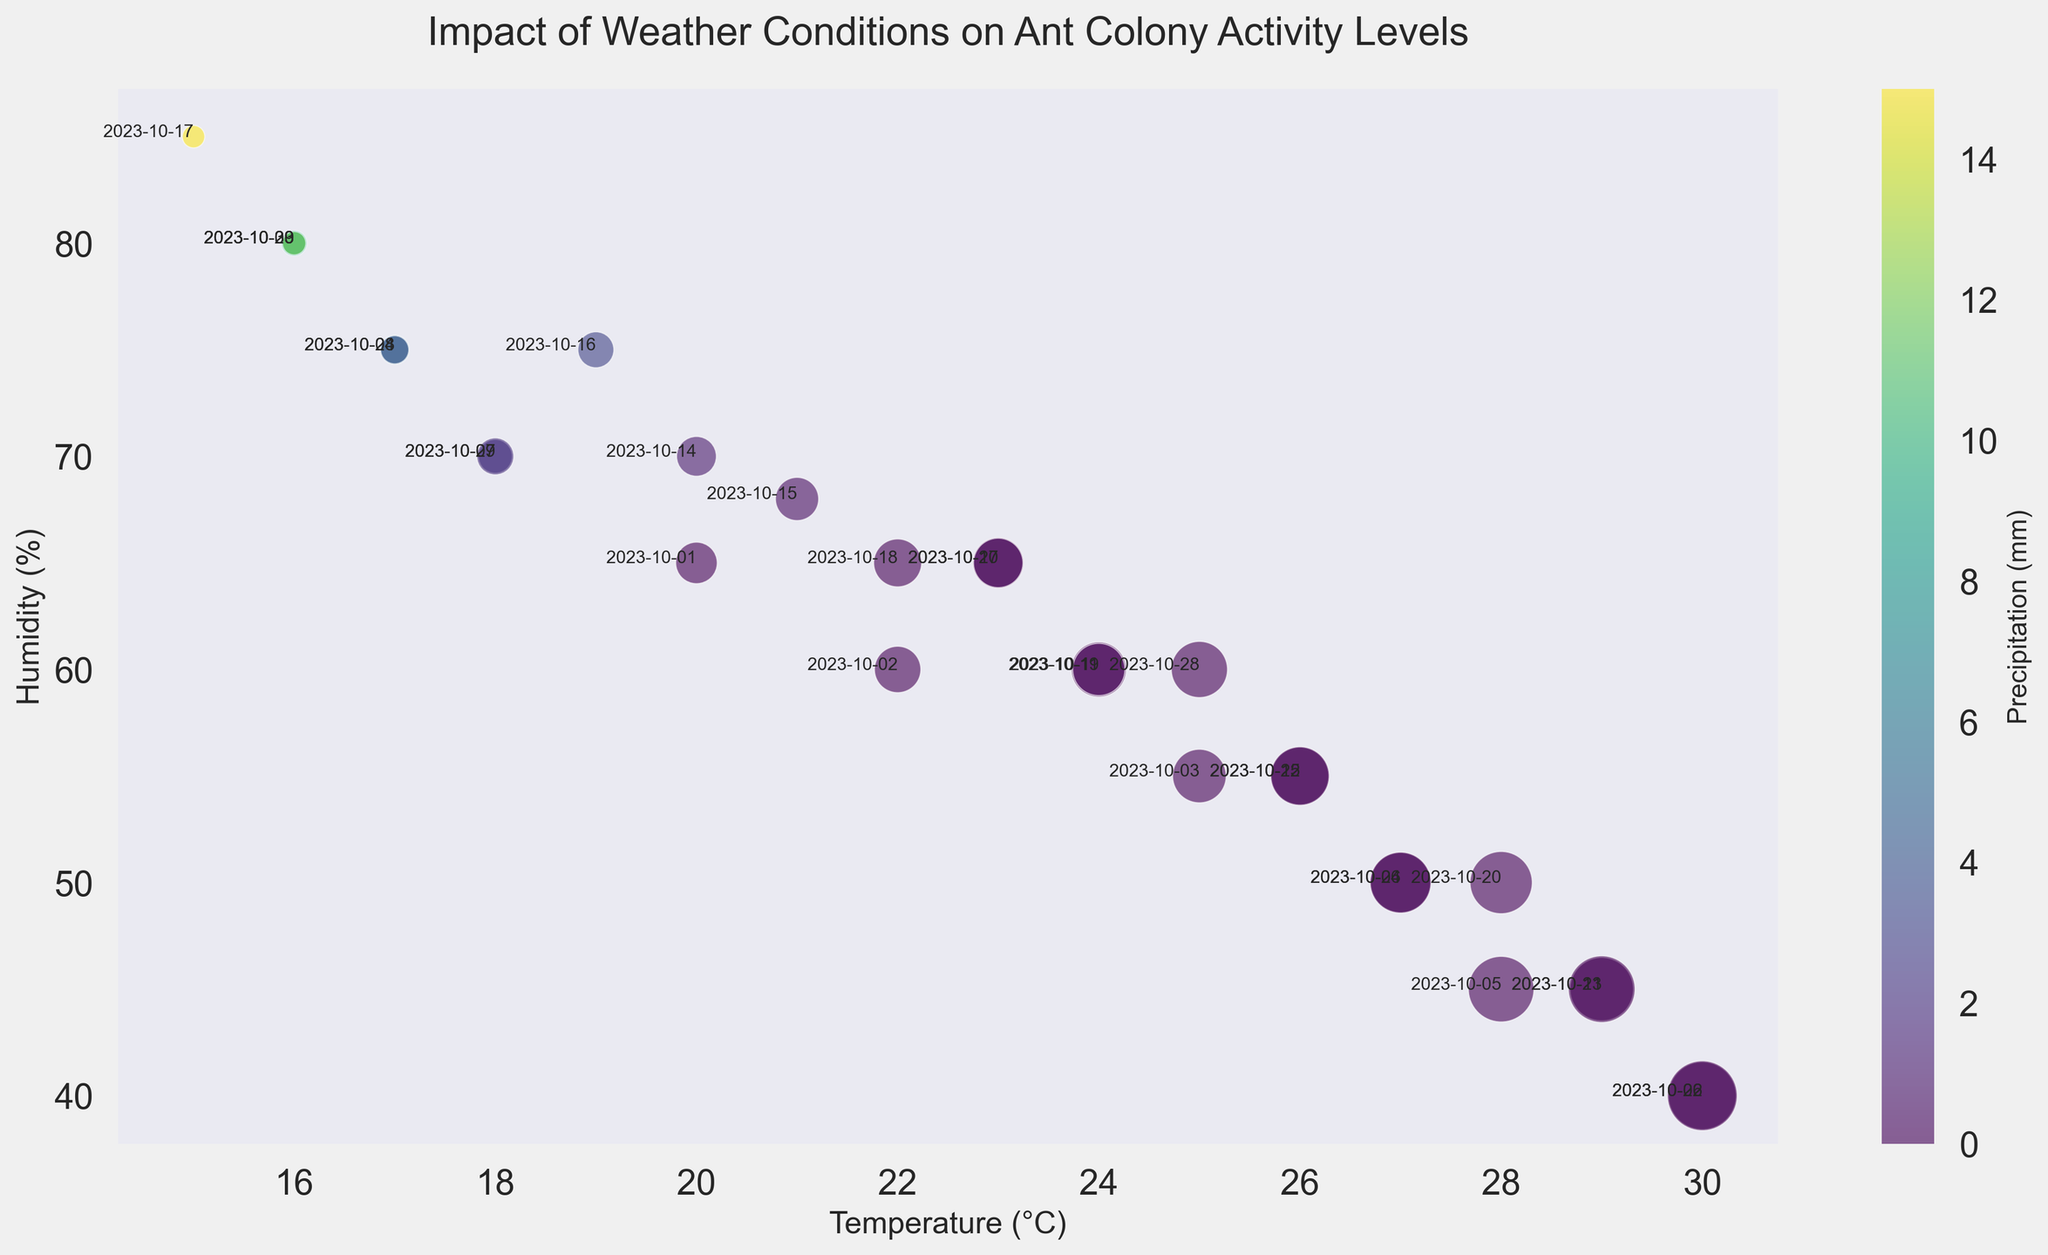What's the highest number of active ants counted on a dry day? First, identify the days with 0.0 mm of precipitation. Then, find the day with the highest number of active ants among those days. The highest count on a dry day is 340 ants on October 22nd.
Answer: 340 Which day had the lowest temperature yet still had more than 100 active ants counted? Look for the lowest temperature where the active ants counted were higher than 100. October 1st had a temperature of 20°C with 120 active ants.
Answer: October 1st What temperature range had the most days of precipitation? Identify the temperature ranges where precipitation is greater than 0.0 mm and count the days within each range. Most days with precipitation fall in the range of 15°C to 19°C.
Answer: 15°C to 19°C What was the precipitation level on the day with the maximum temperature and how many active ants were counted? First determine the day with the maximum temperature (30°C). The days with this temperature are October 6th and 22nd, each with different levels of precipitation, the data shows 0.0 mm. The number of active ants counted was 320 and 340 respectively.
Answer: 0.0 mm, 320 and 340 On which day was there the highest humidity and what was the temperature on that day? Identify the day with the highest humidity value (85%). The highest humidity was on October 17th and the temperature was 15°C.
Answer: October 17th, 15°C Compare October 17th and October 2nd by the number of active ants and weather conditions. Look at both days and compare the data. October 17th had 35 ants, 15°C temperature, 85% humidity, and 15.0 mm precipitation. October 2nd had 150 ants, 22°C temperature, 60% humidity, and 0.0 mm precipitation.
Answer: October 2nd had higher ants count and was warmer and drier than October 17th Which day had the closest temperature and humidity values, and how many active ants were recorded on that day? Find the day where temperature and humidity values are closest to each other. October 4th has 27°C temperature and 50% humidity, which are within 23 units apart. Recorded active ants were 250.
Answer: October 4th, 250 What color represents the highest precipitation levels, and how does it compare visually to the days with no precipitation? The highest precipitation levels are in colors on the far end of the color bar (likely dark purple or blue shades). In contrast, days with no precipitation are represented by colors on the other end of the spectrum (likely yellow to green shades).
Answer: Dark purple indicates high precipitation, yellow/green indicates no precipitation Between October 9th and 10th, which day had more favorable conditions for ant activity and why? Evaluate temperature, humidity, and precipitation on both days. October 9th had 16°C, 80% humidity, and 10.0 mm of precipitation with 40 active ants. October 10th had 23°C, 65% humidity, no precipitation, and 180 active ants. Higher temperature and lower precipitation on October 10th made conditions more favorable.
Answer: October 10th had better conditions because of higher temperature and no precipitation 